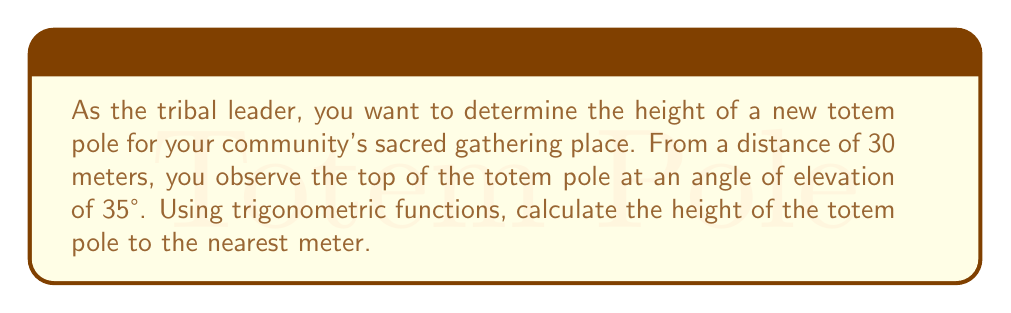What is the answer to this math problem? Let's approach this step-by-step:

1) First, let's visualize the problem:

   [asy]
   import geometry;
   
   size(200);
   
   pair A = (0,0);
   pair B = (6,0);
   pair C = (6,4.2);
   
   draw(A--B--C--A);
   
   label("30 m", (A--B), S);
   label("h", (B--C), E);
   label("35°", A, SW);
   
   draw(arc(A,0.5,0,35), Arrow);
   [/asy]

2) We can see that this forms a right-angled triangle, where:
   - The adjacent side is the distance from the observer to the base of the totem pole (30 meters)
   - The opposite side is the height of the totem pole (h)
   - The angle of elevation is 35°

3) In this scenario, we need to use the tangent function, as we're relating the opposite side to the adjacent side:

   $\tan(\theta) = \frac{\text{opposite}}{\text{adjacent}}$

4) Plugging in our known values:

   $\tan(35°) = \frac{h}{30}$

5) To solve for h, we multiply both sides by 30:

   $30 \cdot \tan(35°) = h$

6) Now we can calculate:

   $h = 30 \cdot \tan(35°) \approx 21.0066$ meters

7) Rounding to the nearest meter as requested:

   $h \approx 21$ meters
Answer: 21 meters 